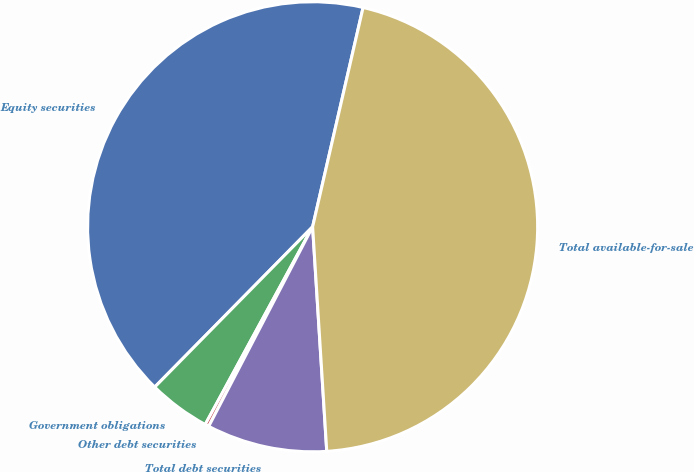<chart> <loc_0><loc_0><loc_500><loc_500><pie_chart><fcel>Equity securities<fcel>Government obligations<fcel>Other debt securities<fcel>Total debt securities<fcel>Total available-for-sale<nl><fcel>41.22%<fcel>4.46%<fcel>0.28%<fcel>8.64%<fcel>45.4%<nl></chart> 